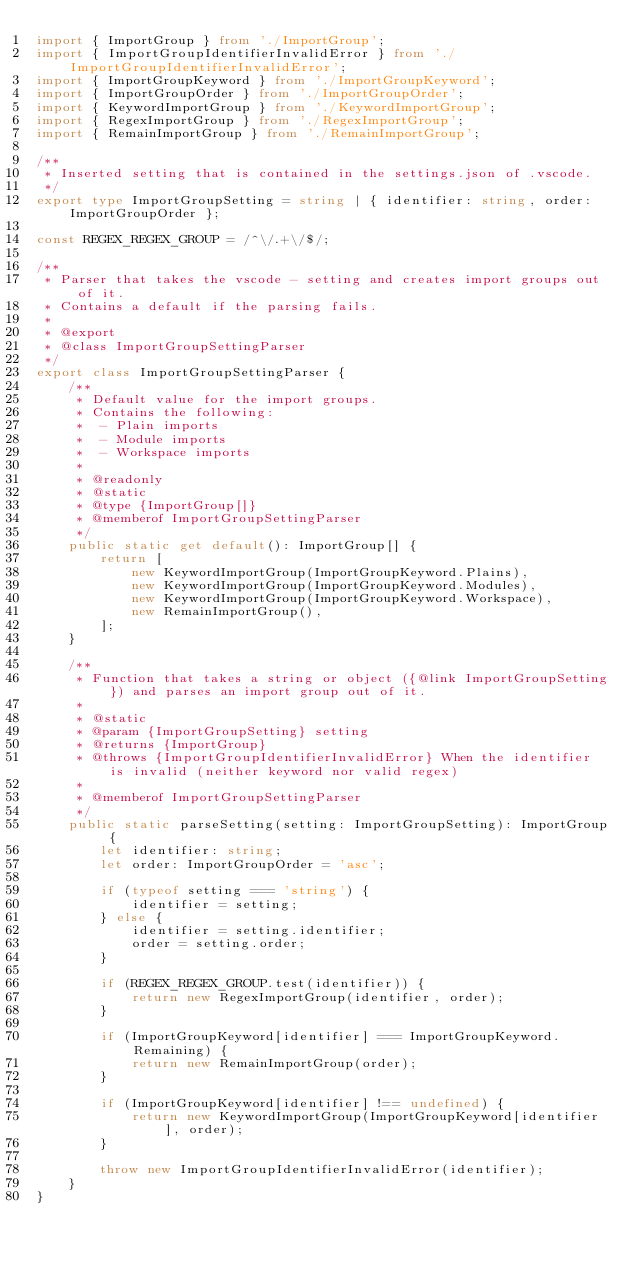<code> <loc_0><loc_0><loc_500><loc_500><_TypeScript_>import { ImportGroup } from './ImportGroup';
import { ImportGroupIdentifierInvalidError } from './ImportGroupIdentifierInvalidError';
import { ImportGroupKeyword } from './ImportGroupKeyword';
import { ImportGroupOrder } from './ImportGroupOrder';
import { KeywordImportGroup } from './KeywordImportGroup';
import { RegexImportGroup } from './RegexImportGroup';
import { RemainImportGroup } from './RemainImportGroup';

/**
 * Inserted setting that is contained in the settings.json of .vscode.
 */
export type ImportGroupSetting = string | { identifier: string, order: ImportGroupOrder };

const REGEX_REGEX_GROUP = /^\/.+\/$/;

/**
 * Parser that takes the vscode - setting and creates import groups out of it.
 * Contains a default if the parsing fails.
 *
 * @export
 * @class ImportGroupSettingParser
 */
export class ImportGroupSettingParser {
    /**
     * Default value for the import groups.
     * Contains the following:
     *  - Plain imports
     *  - Module imports
     *  - Workspace imports
     *
     * @readonly
     * @static
     * @type {ImportGroup[]}
     * @memberof ImportGroupSettingParser
     */
    public static get default(): ImportGroup[] {
        return [
            new KeywordImportGroup(ImportGroupKeyword.Plains),
            new KeywordImportGroup(ImportGroupKeyword.Modules),
            new KeywordImportGroup(ImportGroupKeyword.Workspace),
            new RemainImportGroup(),
        ];
    }

    /**
     * Function that takes a string or object ({@link ImportGroupSetting}) and parses an import group out of it.
     *
     * @static
     * @param {ImportGroupSetting} setting
     * @returns {ImportGroup}
     * @throws {ImportGroupIdentifierInvalidError} When the identifier is invalid (neither keyword nor valid regex)
     *
     * @memberof ImportGroupSettingParser
     */
    public static parseSetting(setting: ImportGroupSetting): ImportGroup {
        let identifier: string;
        let order: ImportGroupOrder = 'asc';

        if (typeof setting === 'string') {
            identifier = setting;
        } else {
            identifier = setting.identifier;
            order = setting.order;
        }

        if (REGEX_REGEX_GROUP.test(identifier)) {
            return new RegexImportGroup(identifier, order);
        }

        if (ImportGroupKeyword[identifier] === ImportGroupKeyword.Remaining) {
            return new RemainImportGroup(order);
        }

        if (ImportGroupKeyword[identifier] !== undefined) {
            return new KeywordImportGroup(ImportGroupKeyword[identifier], order);
        }

        throw new ImportGroupIdentifierInvalidError(identifier);
    }
}
</code> 